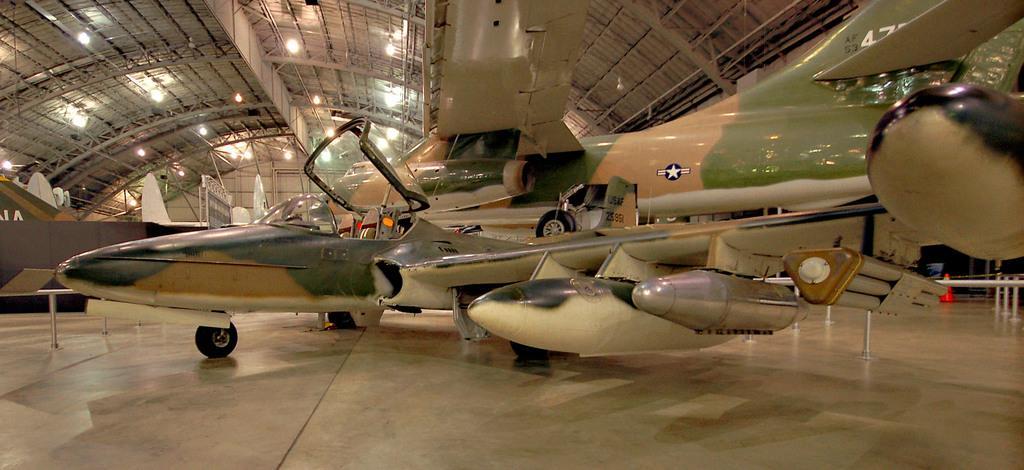Can you describe this image briefly? In this image there is an aeroplane in the hanger. 